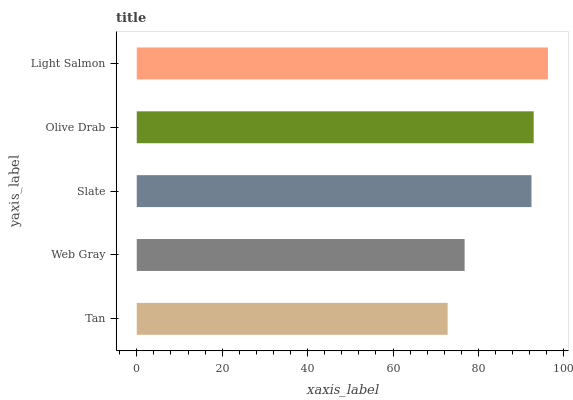Is Tan the minimum?
Answer yes or no. Yes. Is Light Salmon the maximum?
Answer yes or no. Yes. Is Web Gray the minimum?
Answer yes or no. No. Is Web Gray the maximum?
Answer yes or no. No. Is Web Gray greater than Tan?
Answer yes or no. Yes. Is Tan less than Web Gray?
Answer yes or no. Yes. Is Tan greater than Web Gray?
Answer yes or no. No. Is Web Gray less than Tan?
Answer yes or no. No. Is Slate the high median?
Answer yes or no. Yes. Is Slate the low median?
Answer yes or no. Yes. Is Web Gray the high median?
Answer yes or no. No. Is Olive Drab the low median?
Answer yes or no. No. 